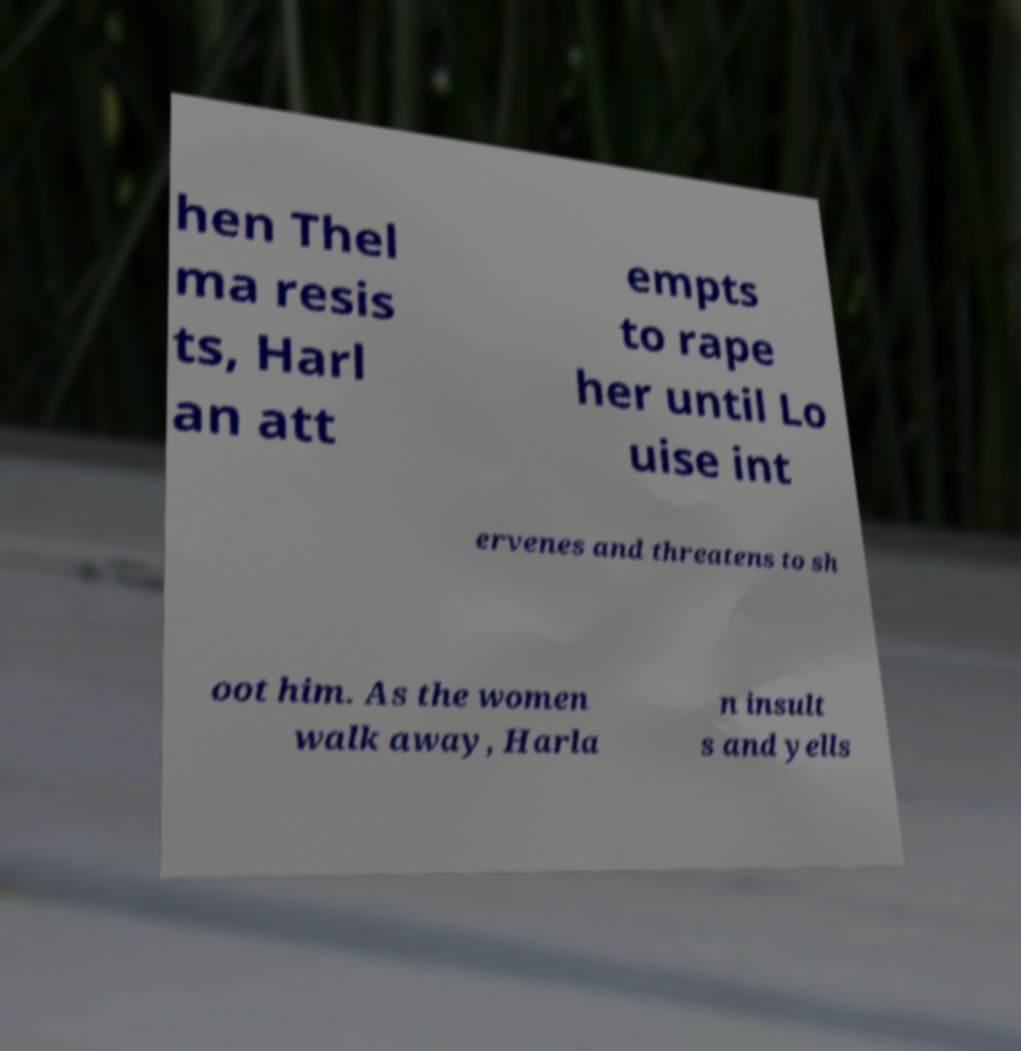Could you assist in decoding the text presented in this image and type it out clearly? hen Thel ma resis ts, Harl an att empts to rape her until Lo uise int ervenes and threatens to sh oot him. As the women walk away, Harla n insult s and yells 